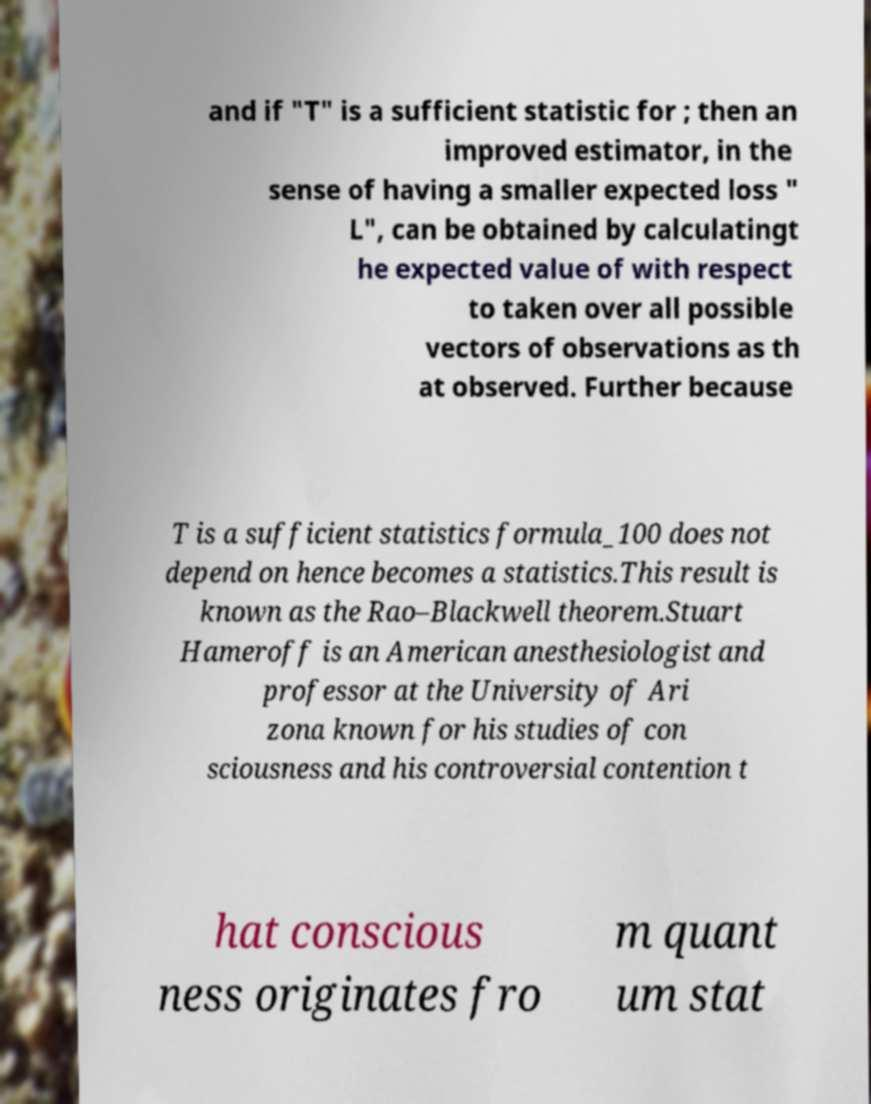For documentation purposes, I need the text within this image transcribed. Could you provide that? and if "T" is a sufficient statistic for ; then an improved estimator, in the sense of having a smaller expected loss " L", can be obtained by calculatingt he expected value of with respect to taken over all possible vectors of observations as th at observed. Further because T is a sufficient statistics formula_100 does not depend on hence becomes a statistics.This result is known as the Rao–Blackwell theorem.Stuart Hameroff is an American anesthesiologist and professor at the University of Ari zona known for his studies of con sciousness and his controversial contention t hat conscious ness originates fro m quant um stat 